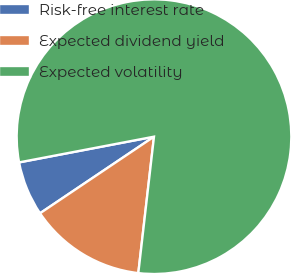Convert chart. <chart><loc_0><loc_0><loc_500><loc_500><pie_chart><fcel>Risk-free interest rate<fcel>Expected dividend yield<fcel>Expected volatility<nl><fcel>6.42%<fcel>13.76%<fcel>79.82%<nl></chart> 